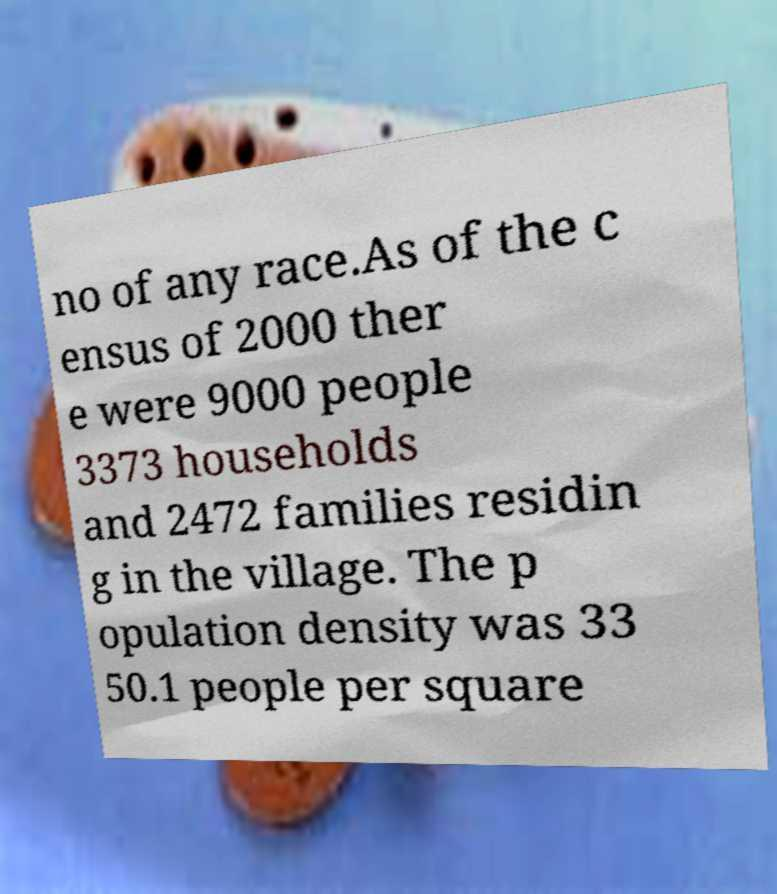There's text embedded in this image that I need extracted. Can you transcribe it verbatim? no of any race.As of the c ensus of 2000 ther e were 9000 people 3373 households and 2472 families residin g in the village. The p opulation density was 33 50.1 people per square 